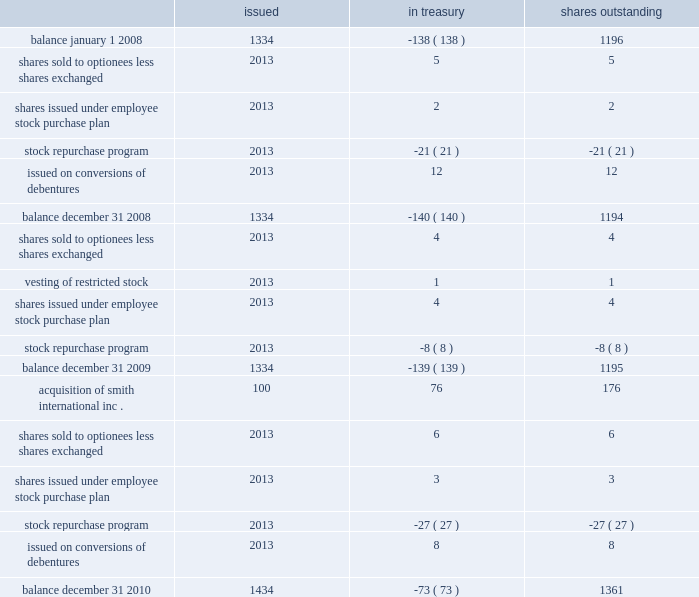Schlumberger limited and subsidiaries shares of common stock issued in treasury shares outstanding ( stated in millions ) .
See the notes to consolidated financial statements part ii , item 8 .
What was the average beginning and ending balance of shares in millions outstanding during 2009? 
Computations: ((1194 + 1195) / 2)
Answer: 1194.5. 